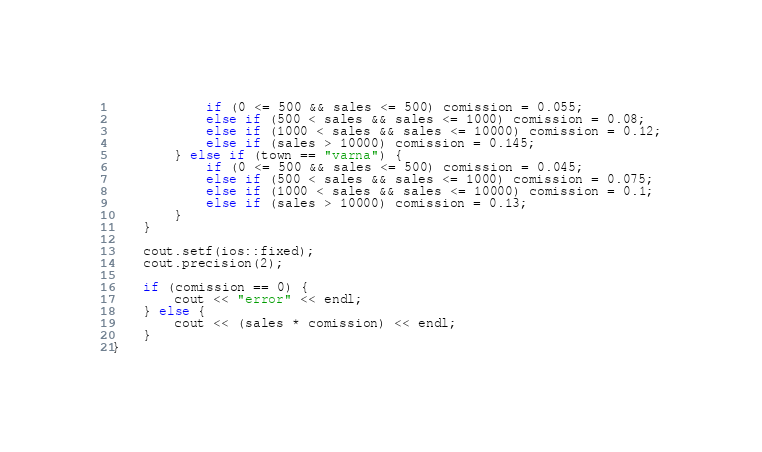Convert code to text. <code><loc_0><loc_0><loc_500><loc_500><_C++_>			if (0 <= 500 && sales <= 500) comission = 0.055;
			else if (500 < sales && sales <= 1000) comission = 0.08;
			else if (1000 < sales && sales <= 10000) comission = 0.12;
			else if (sales > 10000) comission = 0.145;
		} else if (town == "varna") {
			if (0 <= 500 && sales <= 500) comission = 0.045;
			else if (500 < sales && sales <= 1000) comission = 0.075;
			else if (1000 < sales && sales <= 10000) comission = 0.1;
			else if (sales > 10000) comission = 0.13;
		}
	}

	cout.setf(ios::fixed);
	cout.precision(2);

	if (comission == 0) {
		cout << "error" << endl;
	} else {
		cout << (sales * comission) << endl;
	}
}
</code> 